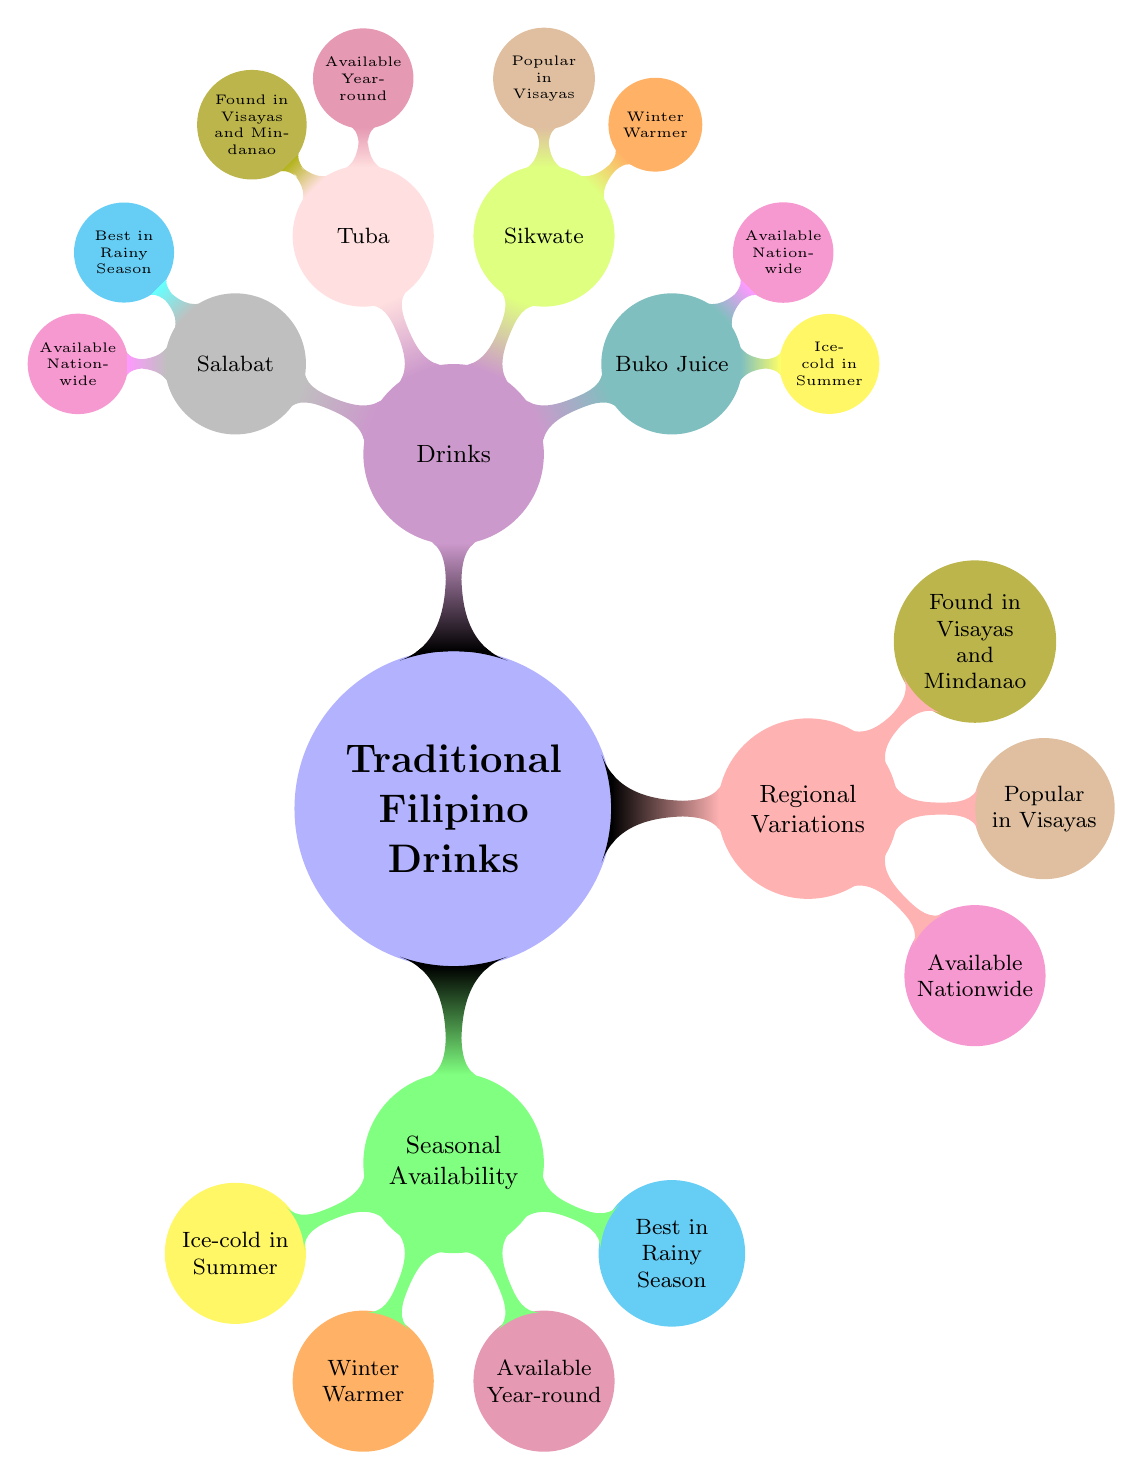What are the two categories of traditional Filipino drinks depicted in the diagram? The diagram highlights "Seasonal Availability" and "Regional Variations" as the two main categories of traditional Filipino drinks.
Answer: Seasonal Availability, Regional Variations How many types of seasonal availability are shown in the diagram? There are four types of seasonal availability listed: Ice-cold in Summer, Winter Warmer, Available Year-round, and Best in Rainy Season.
Answer: 4 Which drink is noted as a winter warmer? The diagram indicates "Sikwate" as the drink that serves as a winter warmer.
Answer: Sikwate Which traditional drink is available year-round? The drink that is available year-round according to the diagram is "Tuba."
Answer: Tuba Where can Sikwate be found primarily? The diagram states that Sikwate is popular in the Visayas region.
Answer: Popular in Visayas How many drinks are listed under the "Drinks" category? There are four drinks listed under the "Drinks" category: Buko Juice, Sikwate, Tuba, and Salabat, making a total of four drinks.
Answer: 4 Of the drinks listed, which one is best in the rainy season? The drink that is best in the rainy season according to the diagram is "Salabat."
Answer: Salabat What is the relationship between Buko Juice and its seasonal availability? Buko Juice is categorized under "Ice-cold in Summer" for its seasonal availability.
Answer: Ice-cold in Summer Which drinks are available nationwide? According to the diagram, "Buko Juice" and "Salabat" are available nationwide.
Answer: Buko Juice, Salabat 